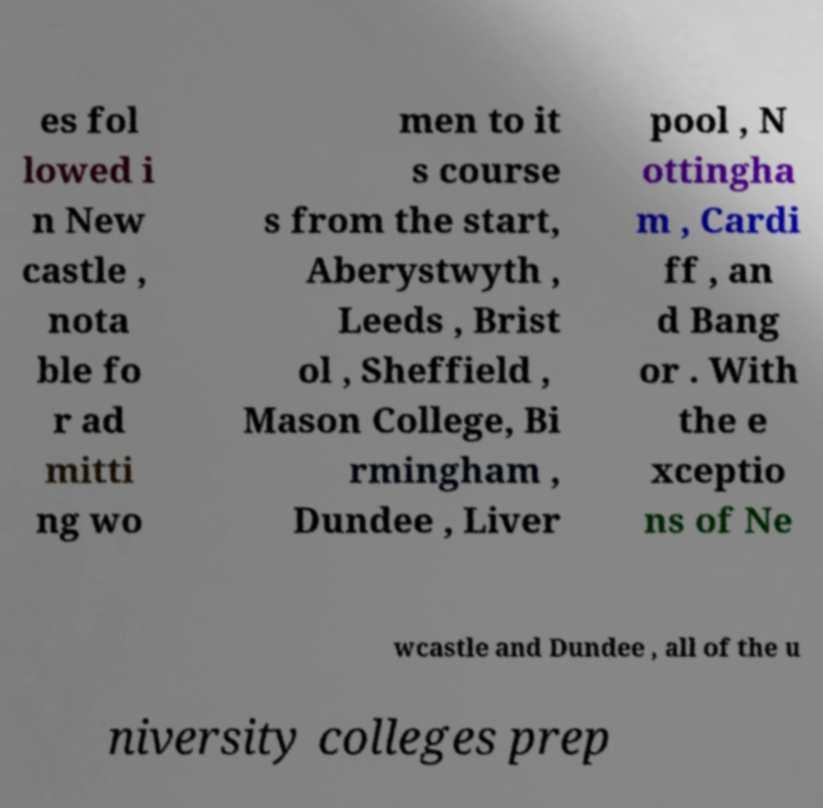Can you accurately transcribe the text from the provided image for me? es fol lowed i n New castle , nota ble fo r ad mitti ng wo men to it s course s from the start, Aberystwyth , Leeds , Brist ol , Sheffield , Mason College, Bi rmingham , Dundee , Liver pool , N ottingha m , Cardi ff , an d Bang or . With the e xceptio ns of Ne wcastle and Dundee , all of the u niversity colleges prep 